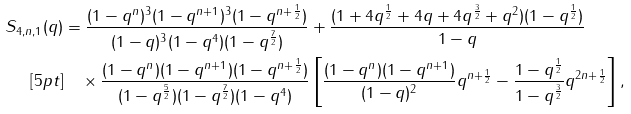<formula> <loc_0><loc_0><loc_500><loc_500>S _ { 4 , n , 1 } ( q ) & = \frac { ( 1 - q ^ { n } ) ^ { 3 } ( 1 - q ^ { n + 1 } ) ^ { 3 } ( 1 - q ^ { n + \frac { 1 } { 2 } } ) } { ( 1 - q ) ^ { 3 } ( 1 - q ^ { 4 } ) ( 1 - q ^ { \frac { 7 } { 2 } } ) } + \frac { ( 1 + 4 q ^ { \frac { 1 } { 2 } } + 4 q + 4 q ^ { \frac { 3 } { 2 } } + q ^ { 2 } ) ( 1 - q ^ { \frac { 1 } { 2 } } ) } { 1 - q } \\ [ 5 p t ] & \quad \times \frac { ( 1 - q ^ { n } ) ( 1 - q ^ { n + 1 } ) ( 1 - q ^ { n + \frac { 1 } { 2 } } ) } { ( 1 - q ^ { \frac { 5 } { 2 } } ) ( 1 - q ^ { \frac { 7 } { 2 } } ) ( 1 - q ^ { 4 } ) } \left [ \frac { ( 1 - q ^ { n } ) ( 1 - q ^ { n + 1 } ) } { ( 1 - q ) ^ { 2 } } q ^ { n + \frac { 1 } { 2 } } - \frac { 1 - q ^ { \frac { 1 } { 2 } } } { 1 - q ^ { \frac { 3 } { 2 } } } q ^ { 2 n + \frac { 1 } { 2 } } \right ] ,</formula> 